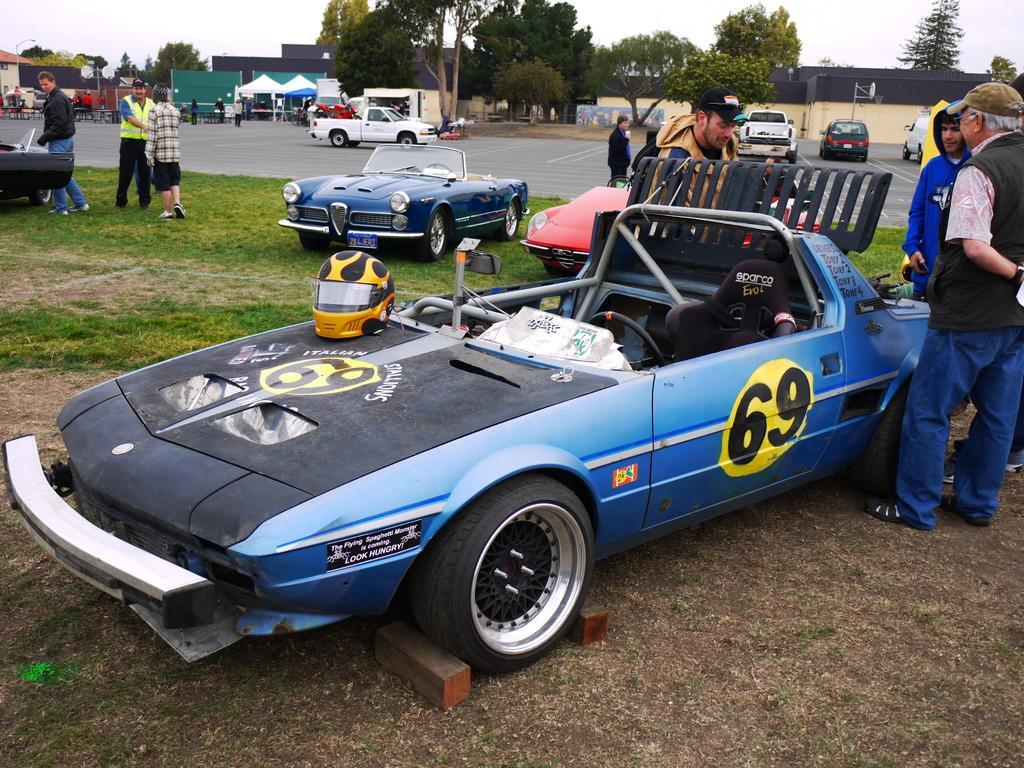Could you give a brief overview of what you see in this image? In this image I can see some cars kept at ground and parked on the road I can see some trees at the top of the image. I can see some people standing far behind. I can see some people standing near the cars. I can see a helmet on the car in the center of the image. 